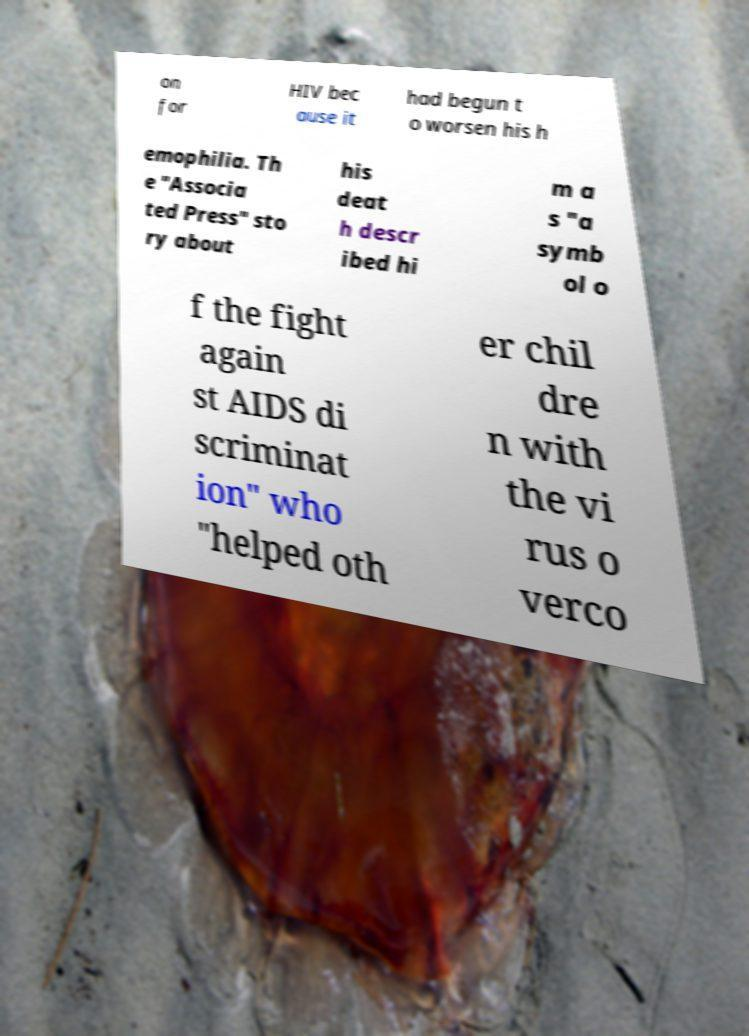There's text embedded in this image that I need extracted. Can you transcribe it verbatim? on for HIV bec ause it had begun t o worsen his h emophilia. Th e "Associa ted Press" sto ry about his deat h descr ibed hi m a s "a symb ol o f the fight again st AIDS di scriminat ion" who "helped oth er chil dre n with the vi rus o verco 